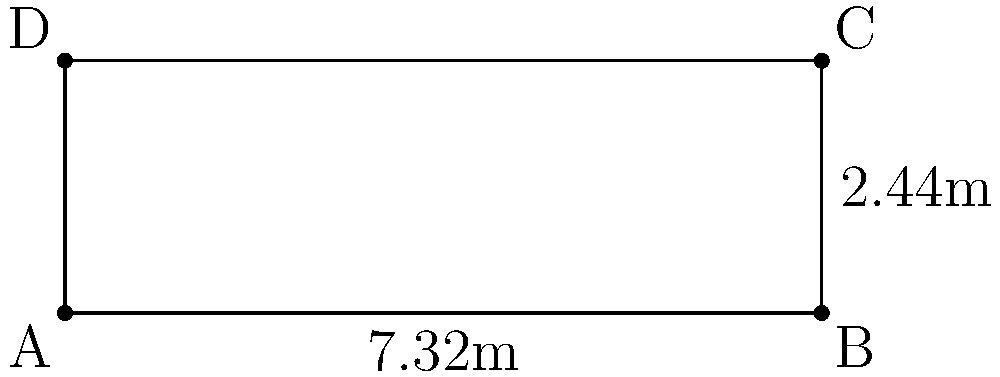In a standard soccer goal, as used in the Bundesliga where Marie Müller plays, the rectangular frame has a width of 7.32 meters and a height of 2.44 meters. If the goal posts and crossbar have a square cross-section with sides of 12 cm, what is the area of the opening through which the ball can pass? Let's approach this step-by-step:

1) First, we need to calculate the inner dimensions of the goal:
   Width: $7.32 \text{ m} - 2 \times 0.12 \text{ m} = 7.08 \text{ m}$
   Height: $2.44 \text{ m} - 0.12 \text{ m} = 2.32 \text{ m}$

2) The area of a rectangle is given by the formula: $A = l \times w$
   Where $A$ is the area, $l$ is the length (or height in this case), and $w$ is the width.

3) Substituting our values:
   $A = 2.32 \text{ m} \times 7.08 \text{ m}$

4) Calculating:
   $A = 16.4256 \text{ m}^2$

5) Rounding to two decimal places:
   $A \approx 16.43 \text{ m}^2$
Answer: $16.43 \text{ m}^2$ 